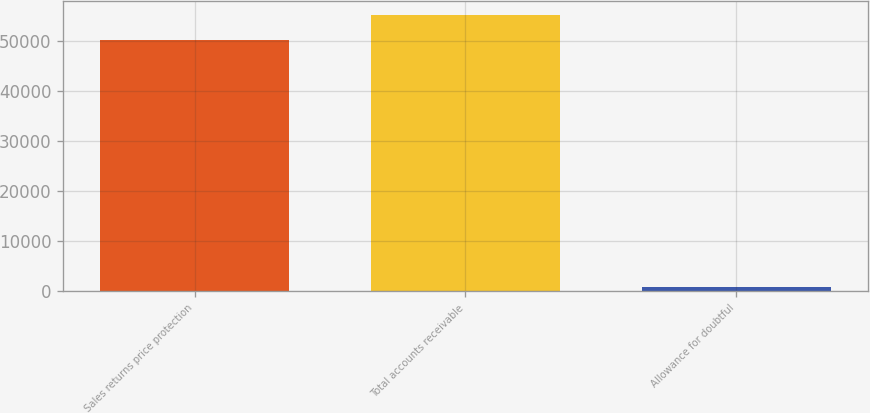<chart> <loc_0><loc_0><loc_500><loc_500><bar_chart><fcel>Sales returns price protection<fcel>Total accounts receivable<fcel>Allowance for doubtful<nl><fcel>50290<fcel>55313.1<fcel>771<nl></chart> 